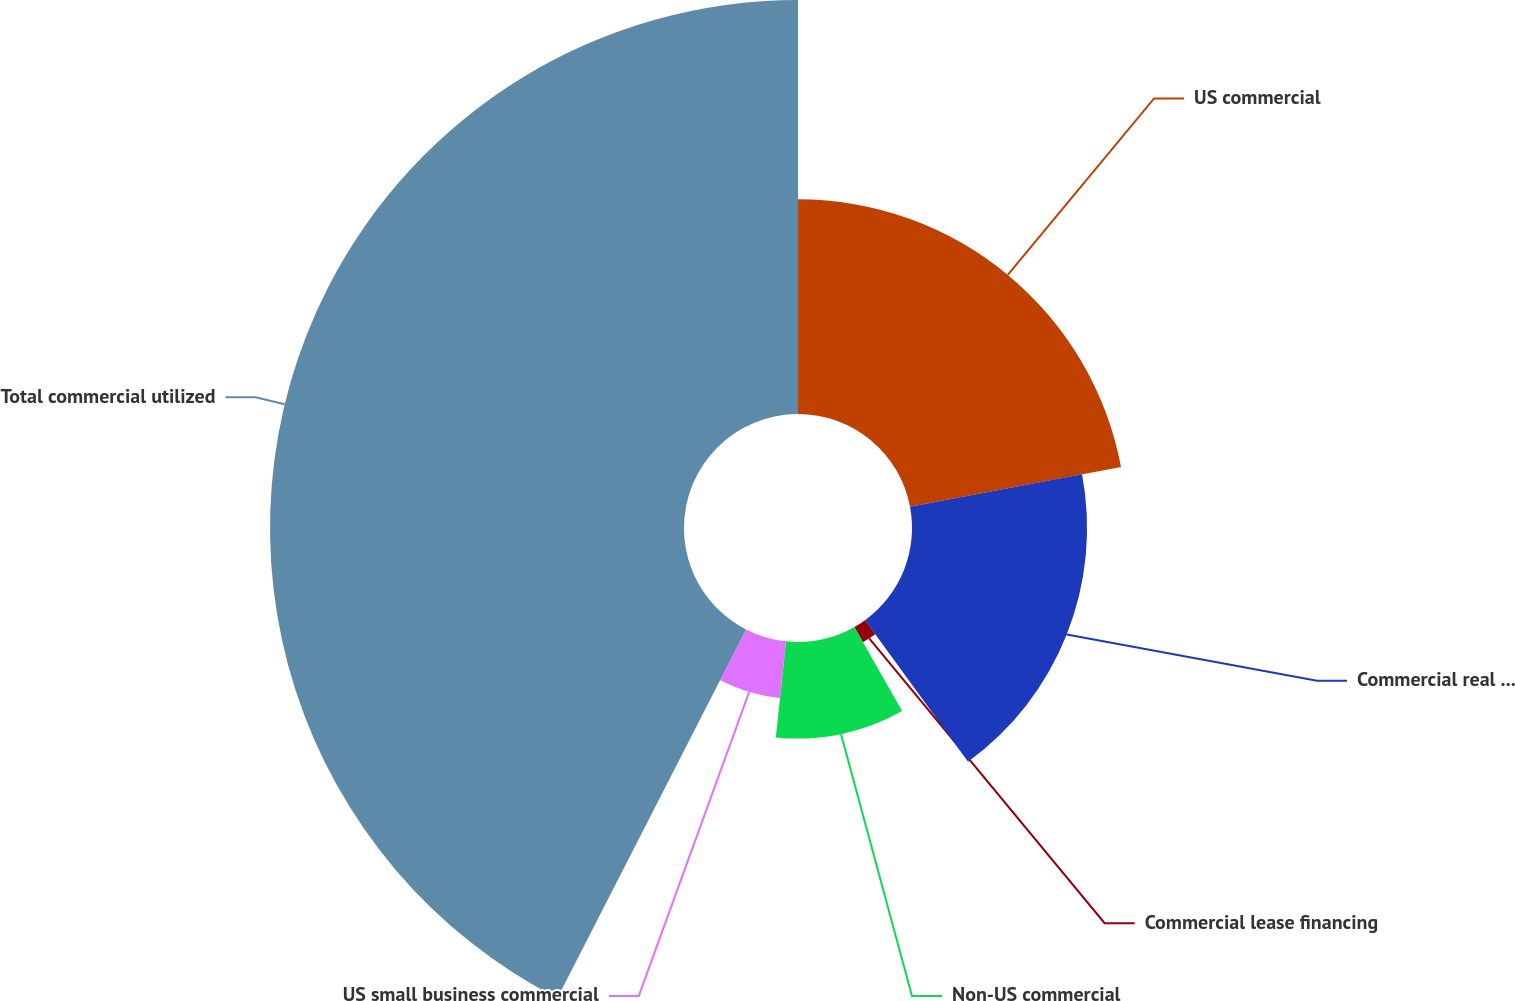Convert chart. <chart><loc_0><loc_0><loc_500><loc_500><pie_chart><fcel>US commercial<fcel>Commercial real estate<fcel>Commercial lease financing<fcel>Non-US commercial<fcel>US small business commercial<fcel>Total commercial utilized<nl><fcel>22.03%<fcel>17.96%<fcel>1.78%<fcel>9.91%<fcel>5.85%<fcel>42.47%<nl></chart> 